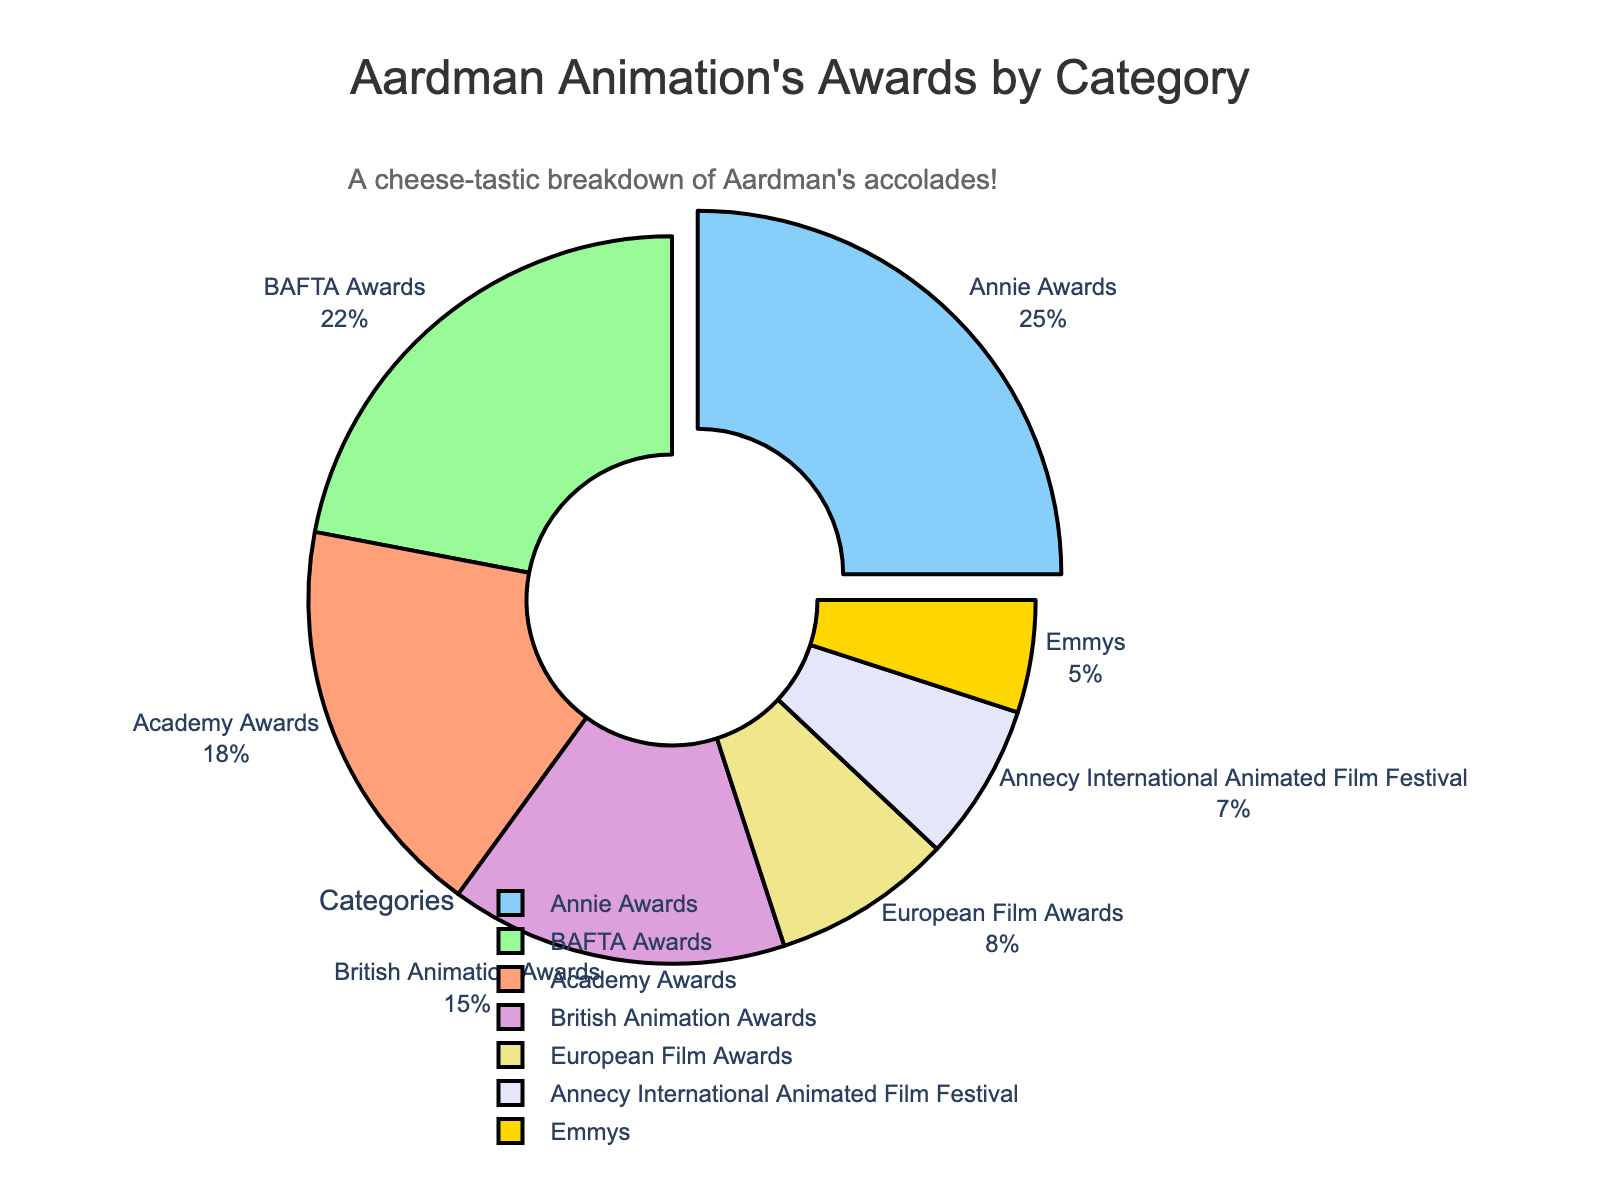Which award category represents the largest percentage of Aardman Animation's awards? The pie chart visually highlights the category with the largest percentage by pulling it out from the rest and giving it a distinct visual emphasis. The highest percentage is the Annie Awards at 25%.
Answer: Annie Awards How much larger is the percentage of BAFTA Awards compared to the Emmys? To find the difference, subtract the percentage of Emmys from the BAFTA Awards. The BAFTA Awards are 22% and the Emmys are 5%. 22% - 5% = 17%.
Answer: 17% What is the total percentage of Aardman Animation's awards attributed to European and Annecy International Animated Film Festival awards combined? Sum the percentages of European Film Awards and Annecy International Animated Film Festival. 8% + 7% = 15%.
Answer: 15% Which award category has the second largest percentage after the Annie Awards? By visually examining the pie chart, the second largest segment after Annie Awards (25%) is BAFTA Awards at 22%.
Answer: BAFTA Awards How many categories have a percentage less than 10%? Visually inspect and count the slices in the pie chart under 10%. European Film Awards (8%), Annecy International Animated Film Festival (7%), and Emmys (5%) qualify. This totals 3 categories.
Answer: 3 If the percent for the Annie and Academy Awards were combined, would it exceed half of the total awards? Sum the percentage for Annie Awards (25%) and Academy Awards (18%). 25% + 18% = 43%. Since 43% is less than 50%, it would not exceed half.
Answer: No Which slice of the pie chart is yellow? Identify the color representing yellow in the pie chart. The British Animation Awards (15%) segment is yellow.
Answer: British Animation Awards What percentage of the awards fall under the categories Academy Awards, BAFTA Awards, and Emmys combined? Sum the percentages of the Academy Awards (18%), BAFTA Awards (22%), and Emmys (5%). 18% + 22% + 5% = 45%.
Answer: 45% Which category has the smallest percentage of awards? Identify the smallest slice in the pie chart visually. The smallest percentage is the Emmys at 5%.
Answer: Emmys 